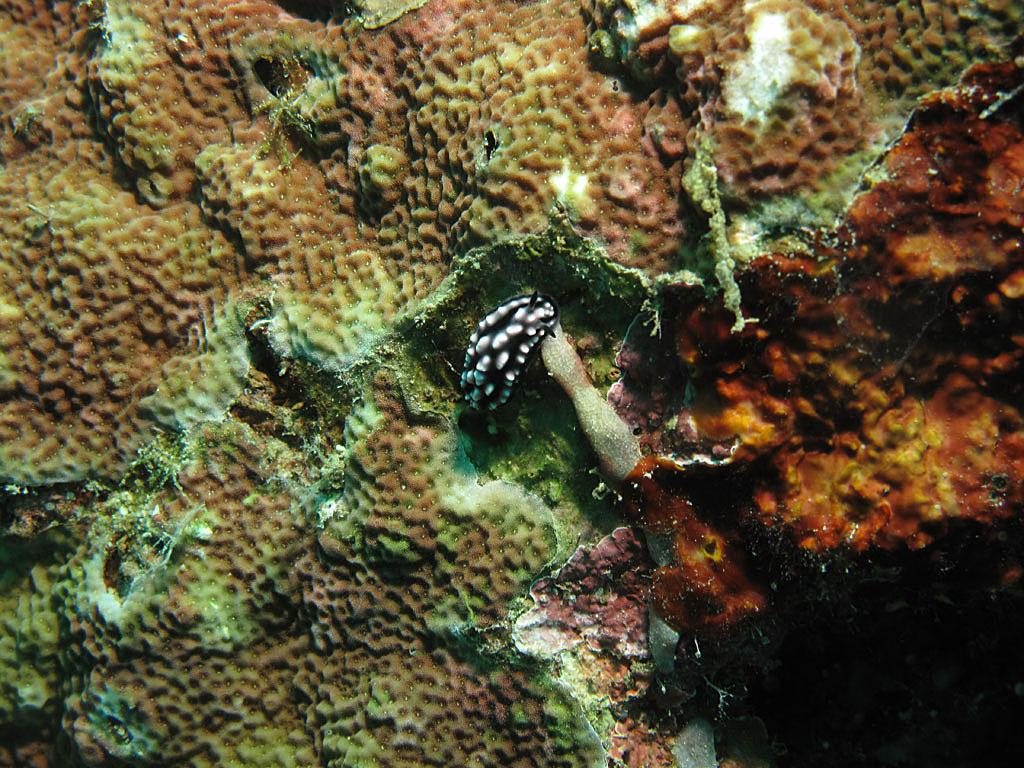What type of environment is shown in the image? The image depicts an underwater environment. Can you identify any living creatures in the image? Yes, there is an animal visible in the image. What type of property does the animal own in the image? There is no indication of property ownership in the image, as it depicts an underwater environment with a focus on the animal's presence. 